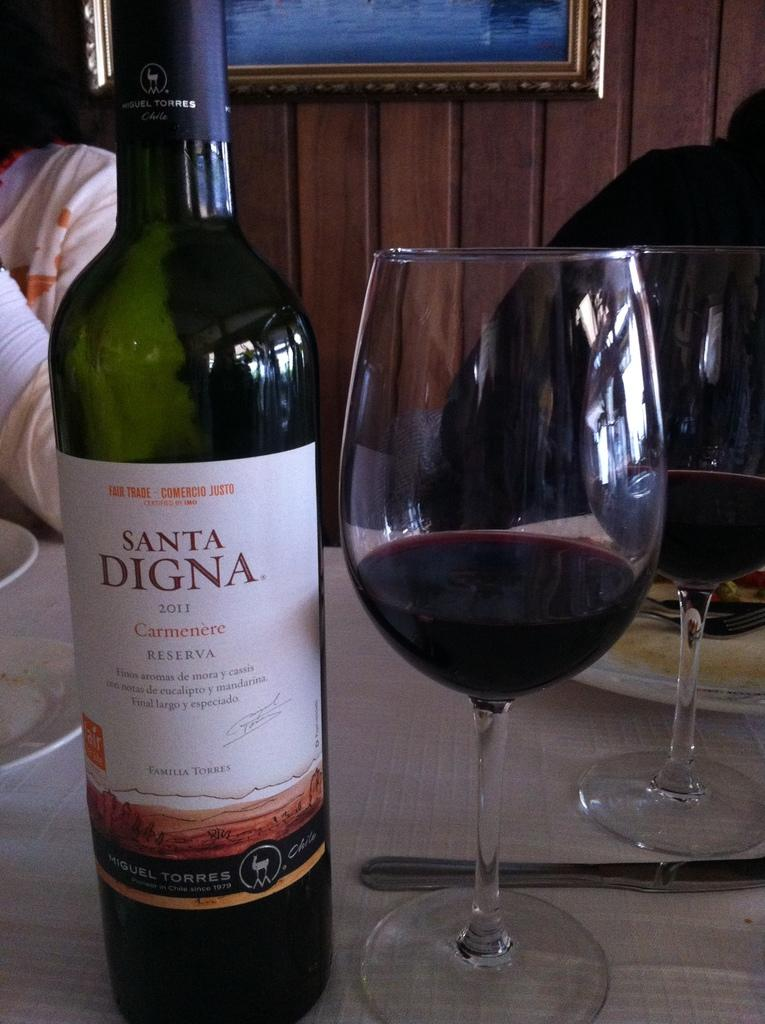<image>
Summarize the visual content of the image. Two glasses of Santa Digna Carmenere are on the table. 